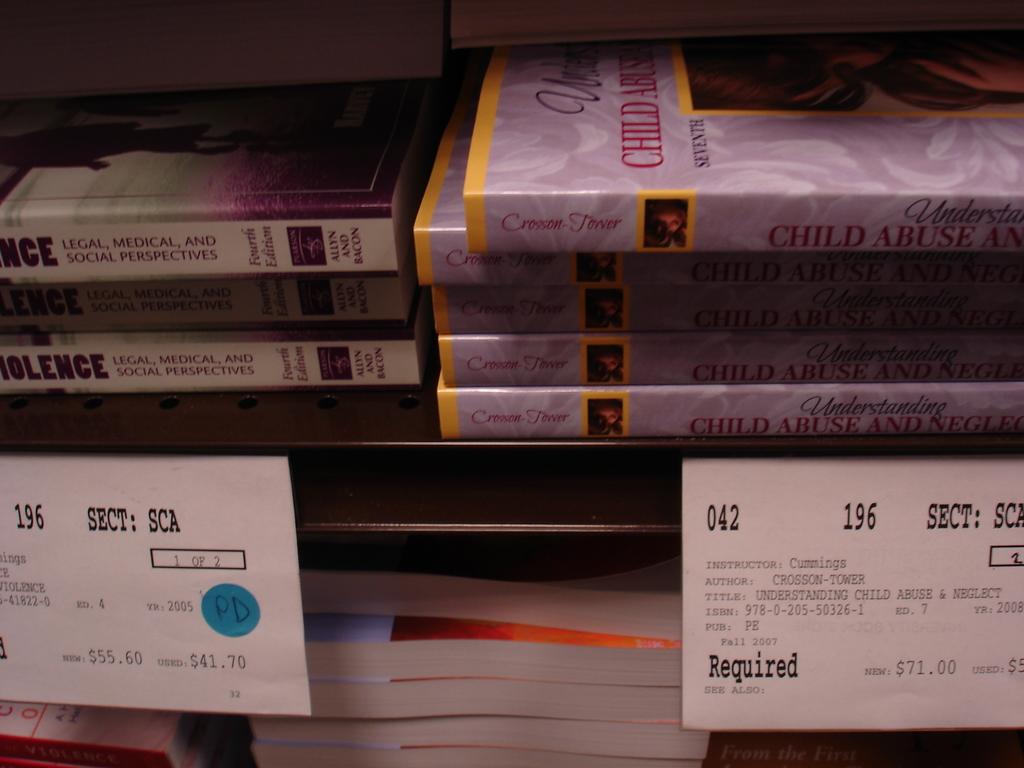What is the price of the book on the right?
Your response must be concise. $71.00. What is the title of the books on the right?
Your answer should be very brief. Understanding child abuse & neglect. 